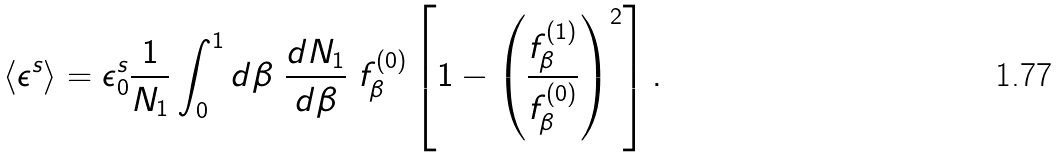<formula> <loc_0><loc_0><loc_500><loc_500>\langle \epsilon ^ { s } \rangle = \epsilon _ { 0 } ^ { s } \frac { 1 } { N _ { 1 } } \int _ { 0 } ^ { 1 } d \beta \ \frac { d N _ { 1 } } { d \beta } \ f _ { \beta } ^ { ( 0 ) } \left [ 1 - \left ( \frac { f _ { \beta } ^ { ( 1 ) } } { f _ { \beta } ^ { ( 0 ) } } \right ) ^ { 2 } \right ] .</formula> 